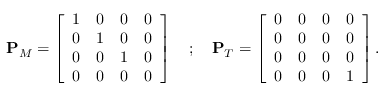Convert formula to latex. <formula><loc_0><loc_0><loc_500><loc_500>\begin{array} { r } { P _ { M } = \left [ \begin{array} { c c c c } { 1 } & { 0 } & { 0 } & { 0 } \\ { 0 } & { 1 } & { 0 } & { 0 } \\ { 0 } & { 0 } & { 1 } & { 0 } \\ { 0 } & { 0 } & { 0 } & { 0 } \end{array} \right ] ; P _ { T } = \left [ \begin{array} { c c c c } { 0 } & { 0 } & { 0 } & { 0 } \\ { 0 } & { 0 } & { 0 } & { 0 } \\ { 0 } & { 0 } & { 0 } & { 0 } \\ { 0 } & { 0 } & { 0 } & { 1 } \end{array} \right ] . } \end{array}</formula> 